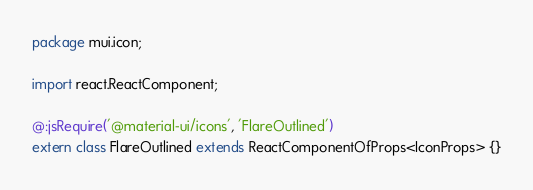<code> <loc_0><loc_0><loc_500><loc_500><_Haxe_>package mui.icon;

import react.ReactComponent;

@:jsRequire('@material-ui/icons', 'FlareOutlined')
extern class FlareOutlined extends ReactComponentOfProps<IconProps> {}
</code> 